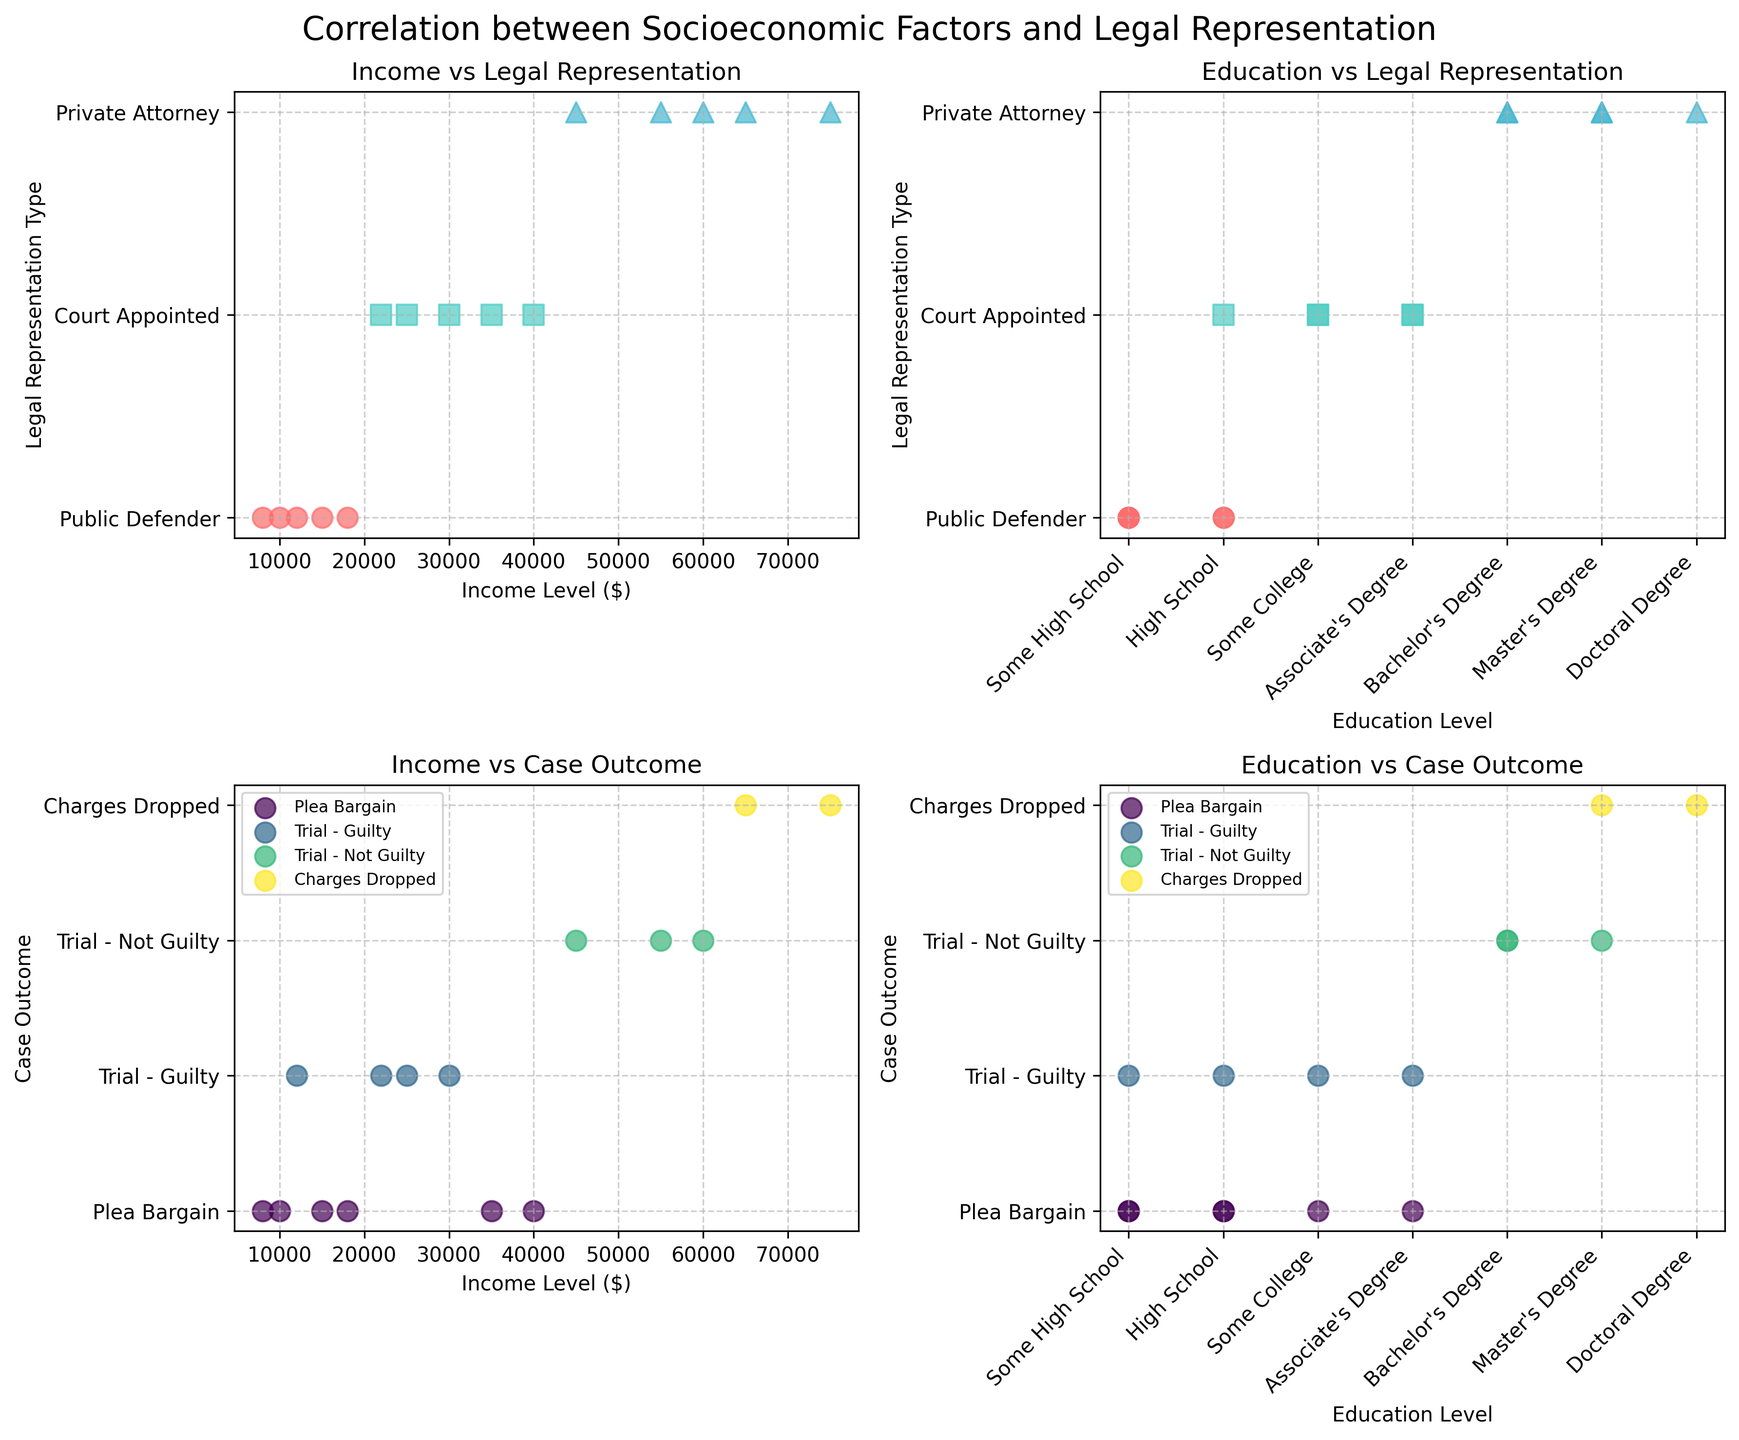What is the title of the figure? The title of the figure is typically found at the top of the plot and summarizes the main topic being visualized. In this case, it is "Correlation between Socioeconomic Factors and Legal Representation".
Answer: Correlation between Socioeconomic Factors and Legal Representation What are the representations used for Public Defender in Plot 1? The representations are indicated by specific colors and markers for each legal representation type. For Public Defender, the data points are represented by red circular markers.
Answer: Red circular markers Which case outcome appears most frequently in Plot 3? To determine the most frequent case outcome, we look at the number of scatter points aligned with each unique outcome on the y-axis. "Plea Bargain" has the most points.
Answer: Plea Bargain How many income levels are visualized for Private Attorney in Plot 1? The scatter plot for income levels vs. legal representation type shows that Private Attorney data points are represented by blue triangular markers. Counting these markers gives us the answer. There are 5 such markers.
Answer: 5 Which education level has the highest representation for Trial - Not Guilty in Plot 4? By counting the scatter points corresponding to "Trial - Not Guilty" along the different education levels, there are more points at Bachelor's Degree.
Answer: Bachelor’s Degree Are higher income levels generally associated with Private Attorneys or Public Defenders in Plot 1? By looking at the income levels along the x-axis for both Private Attorney and Public Defender markers, it’s evident that higher income levels cluster around Private Attorneys.
Answer: Private Attorneys Is there a trend between income level and case outcome in Plot 3? Observing the scatter plot for income levels and corresponding case outcomes, there is a trend where higher income levels are often associated with more favorable outcomes like "Charges Dropped" and "Trial - Not Guilty".
Answer: Higher income levels are associated with favorable outcomes Which legal representation type is most frequently associated with Some High School education level in Plot 2? By examining the scatter points corresponding to "Some High School" on the x-axis, it can be seen that more points align with Public Defender.
Answer: Public Defender What is the range of income levels represented in the figure? The income levels can be found on the x-axes for relevant plots. The minimum income level is $8,000 and the maximum is $75,000.
Answer: $8,000 to $75,000 Is there any correlation between education level and income level among inmates with Private Attorneys? To examine the potential correlation, one would look at the scatter plots showing education and income levels for inmates with means. Higher education levels (Bachelor's, Master's, Doctoral) generally correspond to higher income levels for those with Private Attorneys.
Answer: Higher education levels correspond to higher income levels 